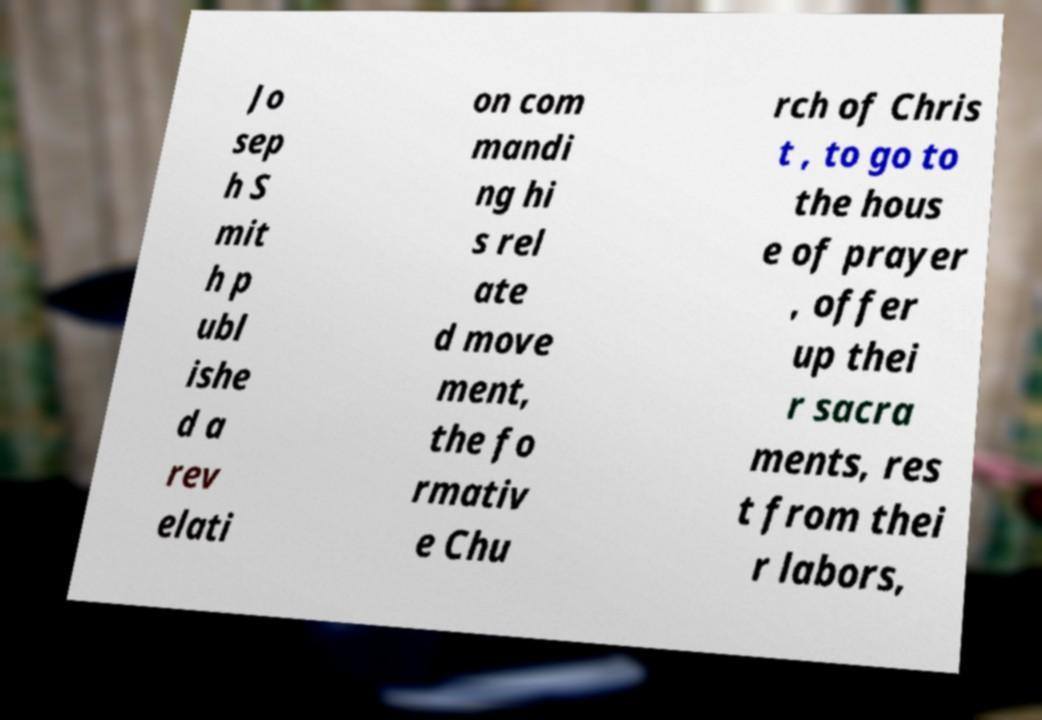Could you extract and type out the text from this image? Jo sep h S mit h p ubl ishe d a rev elati on com mandi ng hi s rel ate d move ment, the fo rmativ e Chu rch of Chris t , to go to the hous e of prayer , offer up thei r sacra ments, res t from thei r labors, 